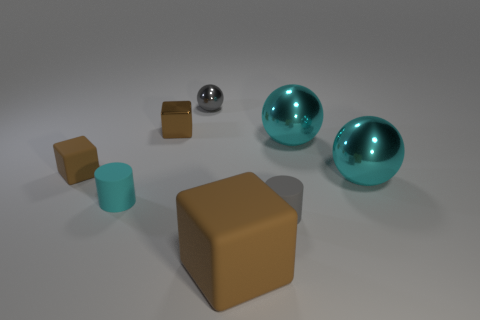Are there more blocks that are in front of the gray cylinder than blocks left of the tiny gray metal ball?
Offer a terse response. No. There is a brown shiny object that is the same size as the cyan matte thing; what shape is it?
Give a very brief answer. Cube. What number of things are tiny brown rubber cubes or objects that are in front of the brown shiny object?
Make the answer very short. 6. Is the color of the big matte cube the same as the metallic block?
Make the answer very short. Yes. How many cyan balls are on the left side of the gray matte cylinder?
Provide a short and direct response. 0. What color is the other cube that is made of the same material as the big block?
Provide a short and direct response. Brown. What number of rubber objects are gray cylinders or small things?
Your answer should be compact. 3. Is the tiny cyan object made of the same material as the gray cylinder?
Provide a succinct answer. Yes. There is a cyan matte thing that is behind the big matte block; what shape is it?
Provide a succinct answer. Cylinder. Are there any spheres that are on the right side of the matte cylinder that is right of the gray sphere?
Your response must be concise. Yes. 